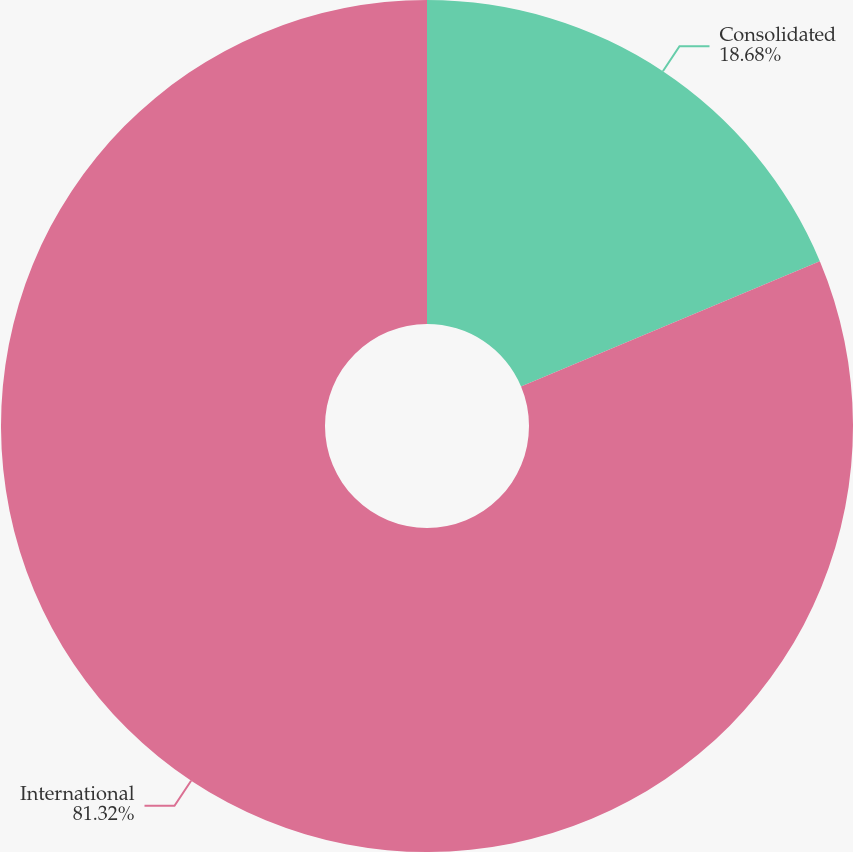Convert chart. <chart><loc_0><loc_0><loc_500><loc_500><pie_chart><fcel>Consolidated<fcel>International<nl><fcel>18.68%<fcel>81.32%<nl></chart> 